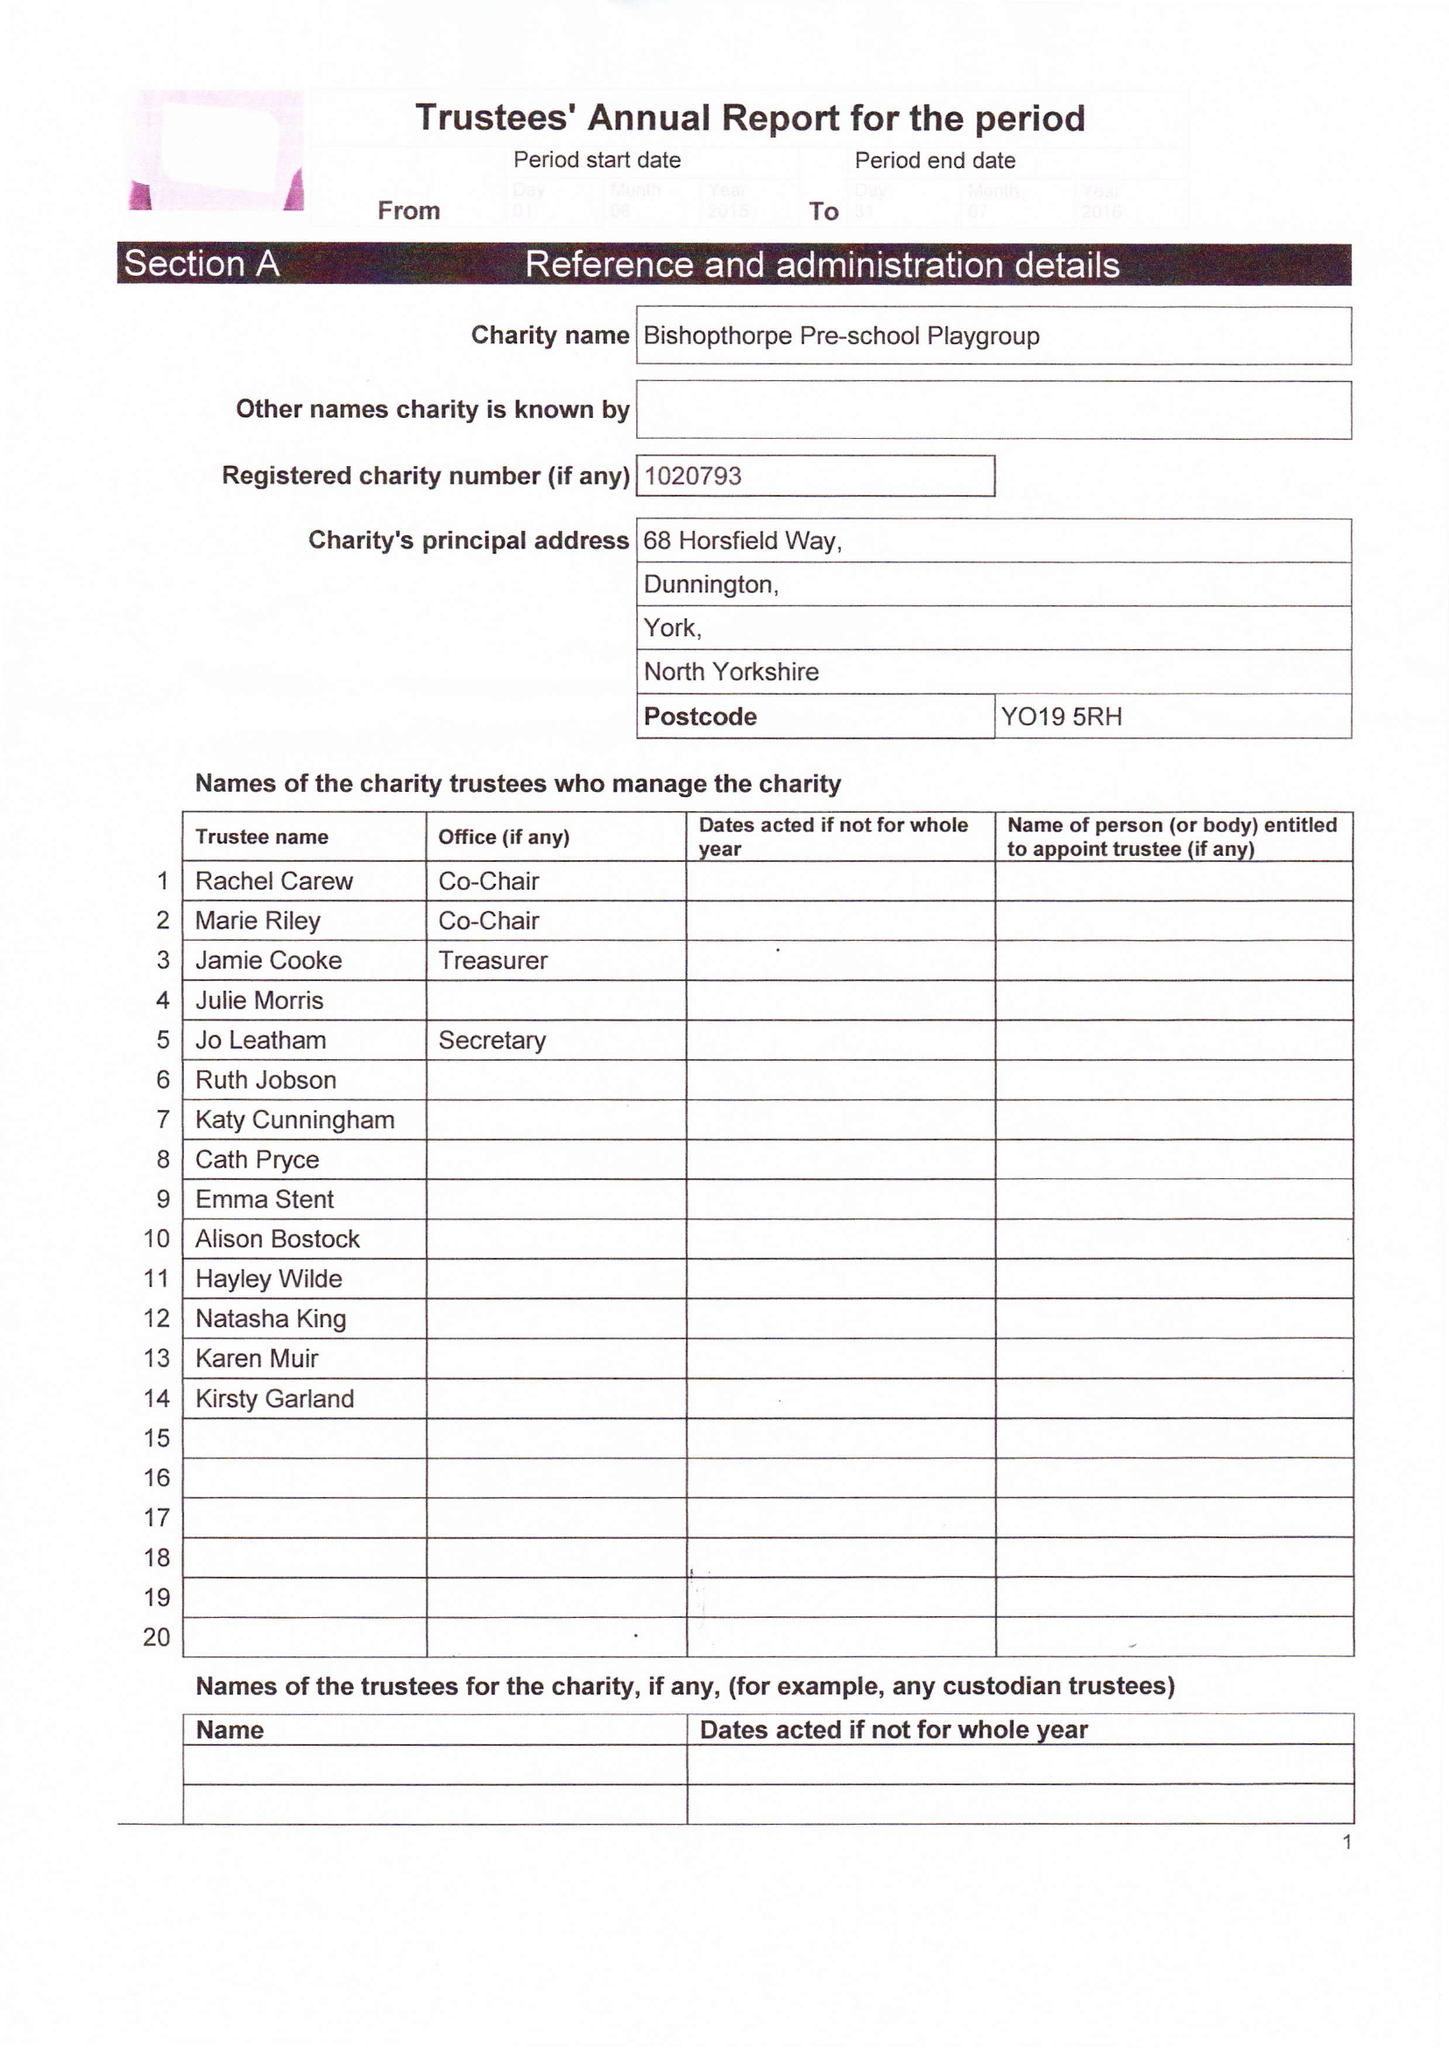What is the value for the address__postcode?
Answer the question using a single word or phrase. YO19 5RH 